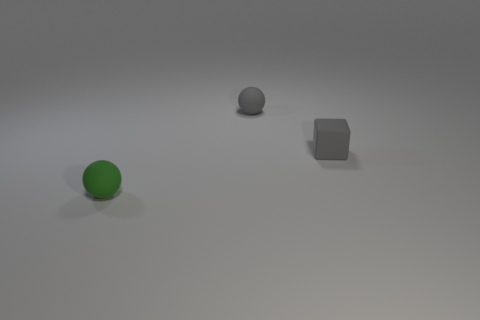Add 3 small blue things. How many objects exist? 6 Subtract all blocks. How many objects are left? 2 Subtract 0 gray cylinders. How many objects are left? 3 Subtract all cubes. Subtract all tiny purple metallic blocks. How many objects are left? 2 Add 1 small blocks. How many small blocks are left? 2 Add 1 rubber balls. How many rubber balls exist? 3 